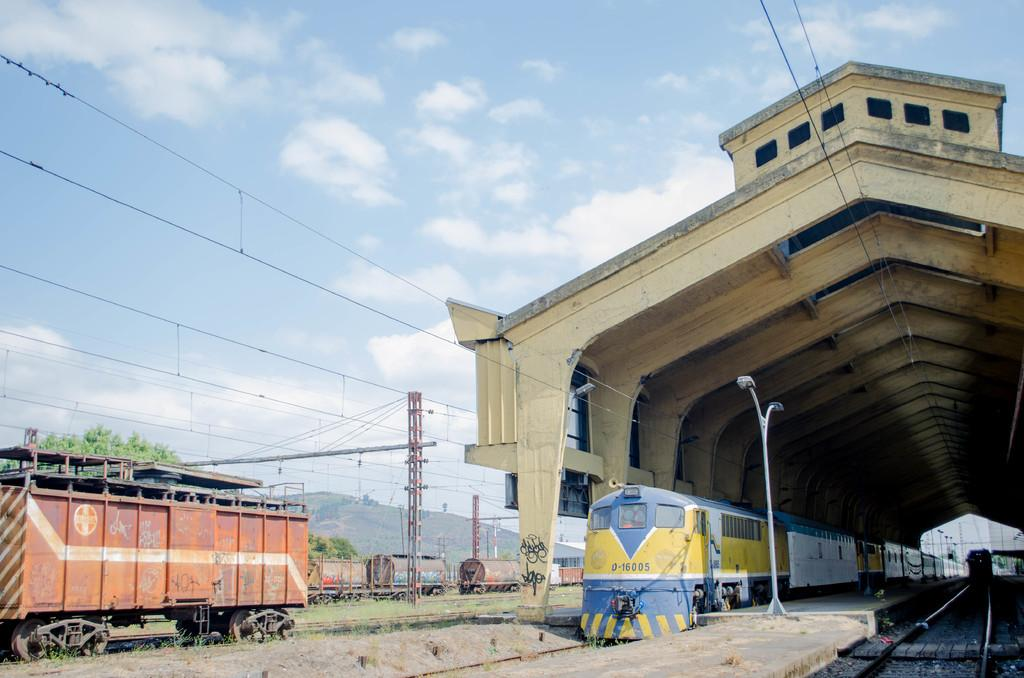What type of transportation infrastructure is visible in the image? There are railway tracks in the image. What is using the railway tracks in the image? Trains are present on the railway tracks. What else can be seen alongside the railway tracks? There are poles, wires, trees, and a tunnel visible in the image. What is visible in the sky in the image? Clouds and the sky are visible in the image. How many kittens are playing on the railway tracks in the image? There are no kittens present in the image. Can you see a robin perched on one of the poles in the image? There is no robin visible in the image. 